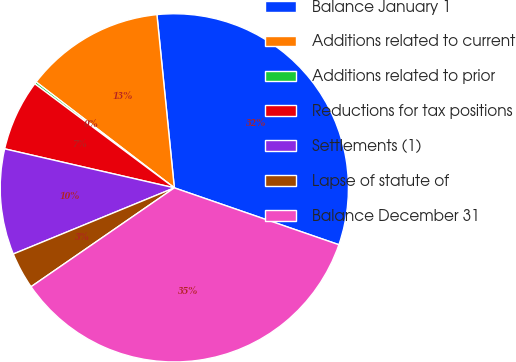<chart> <loc_0><loc_0><loc_500><loc_500><pie_chart><fcel>Balance January 1<fcel>Additions related to current<fcel>Additions related to prior<fcel>Reductions for tax positions<fcel>Settlements (1)<fcel>Lapse of statute of<fcel>Balance December 31<nl><fcel>31.89%<fcel>13.0%<fcel>0.21%<fcel>6.6%<fcel>9.8%<fcel>3.41%<fcel>35.09%<nl></chart> 